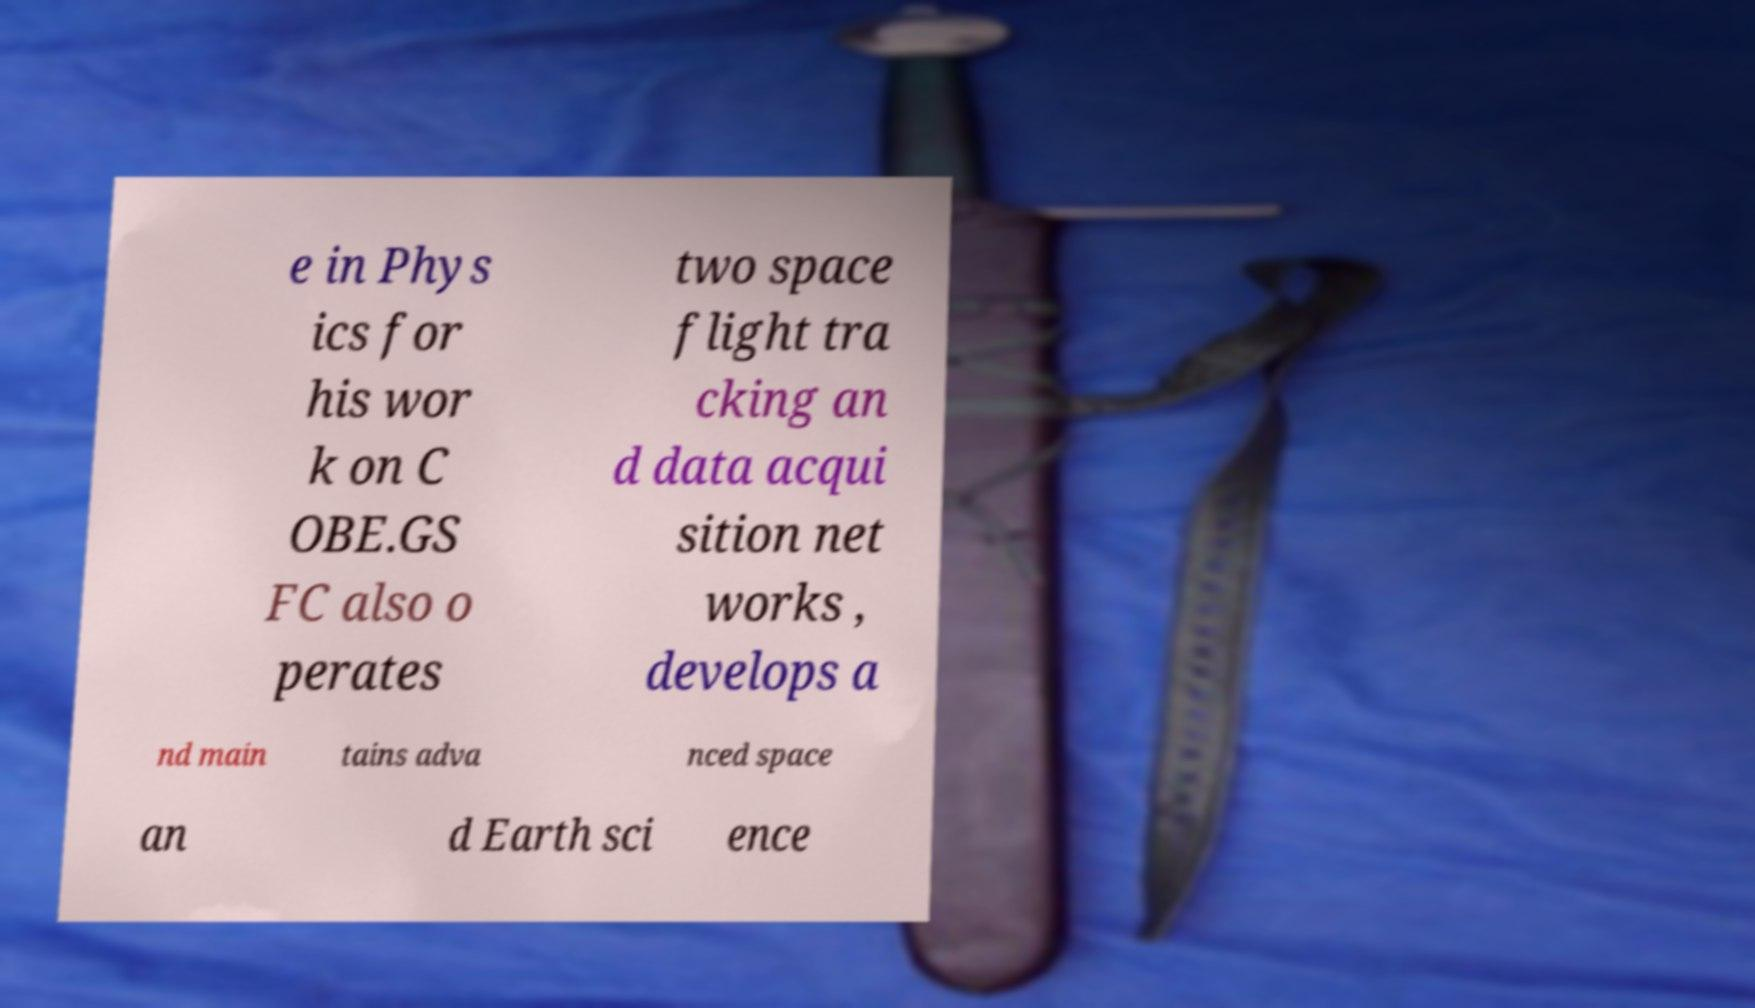Can you accurately transcribe the text from the provided image for me? e in Phys ics for his wor k on C OBE.GS FC also o perates two space flight tra cking an d data acqui sition net works , develops a nd main tains adva nced space an d Earth sci ence 